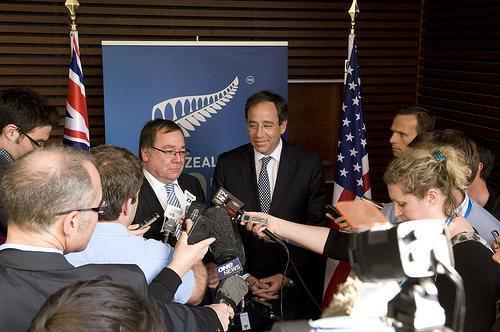How many flags are there?
Give a very brief answer. 2. 